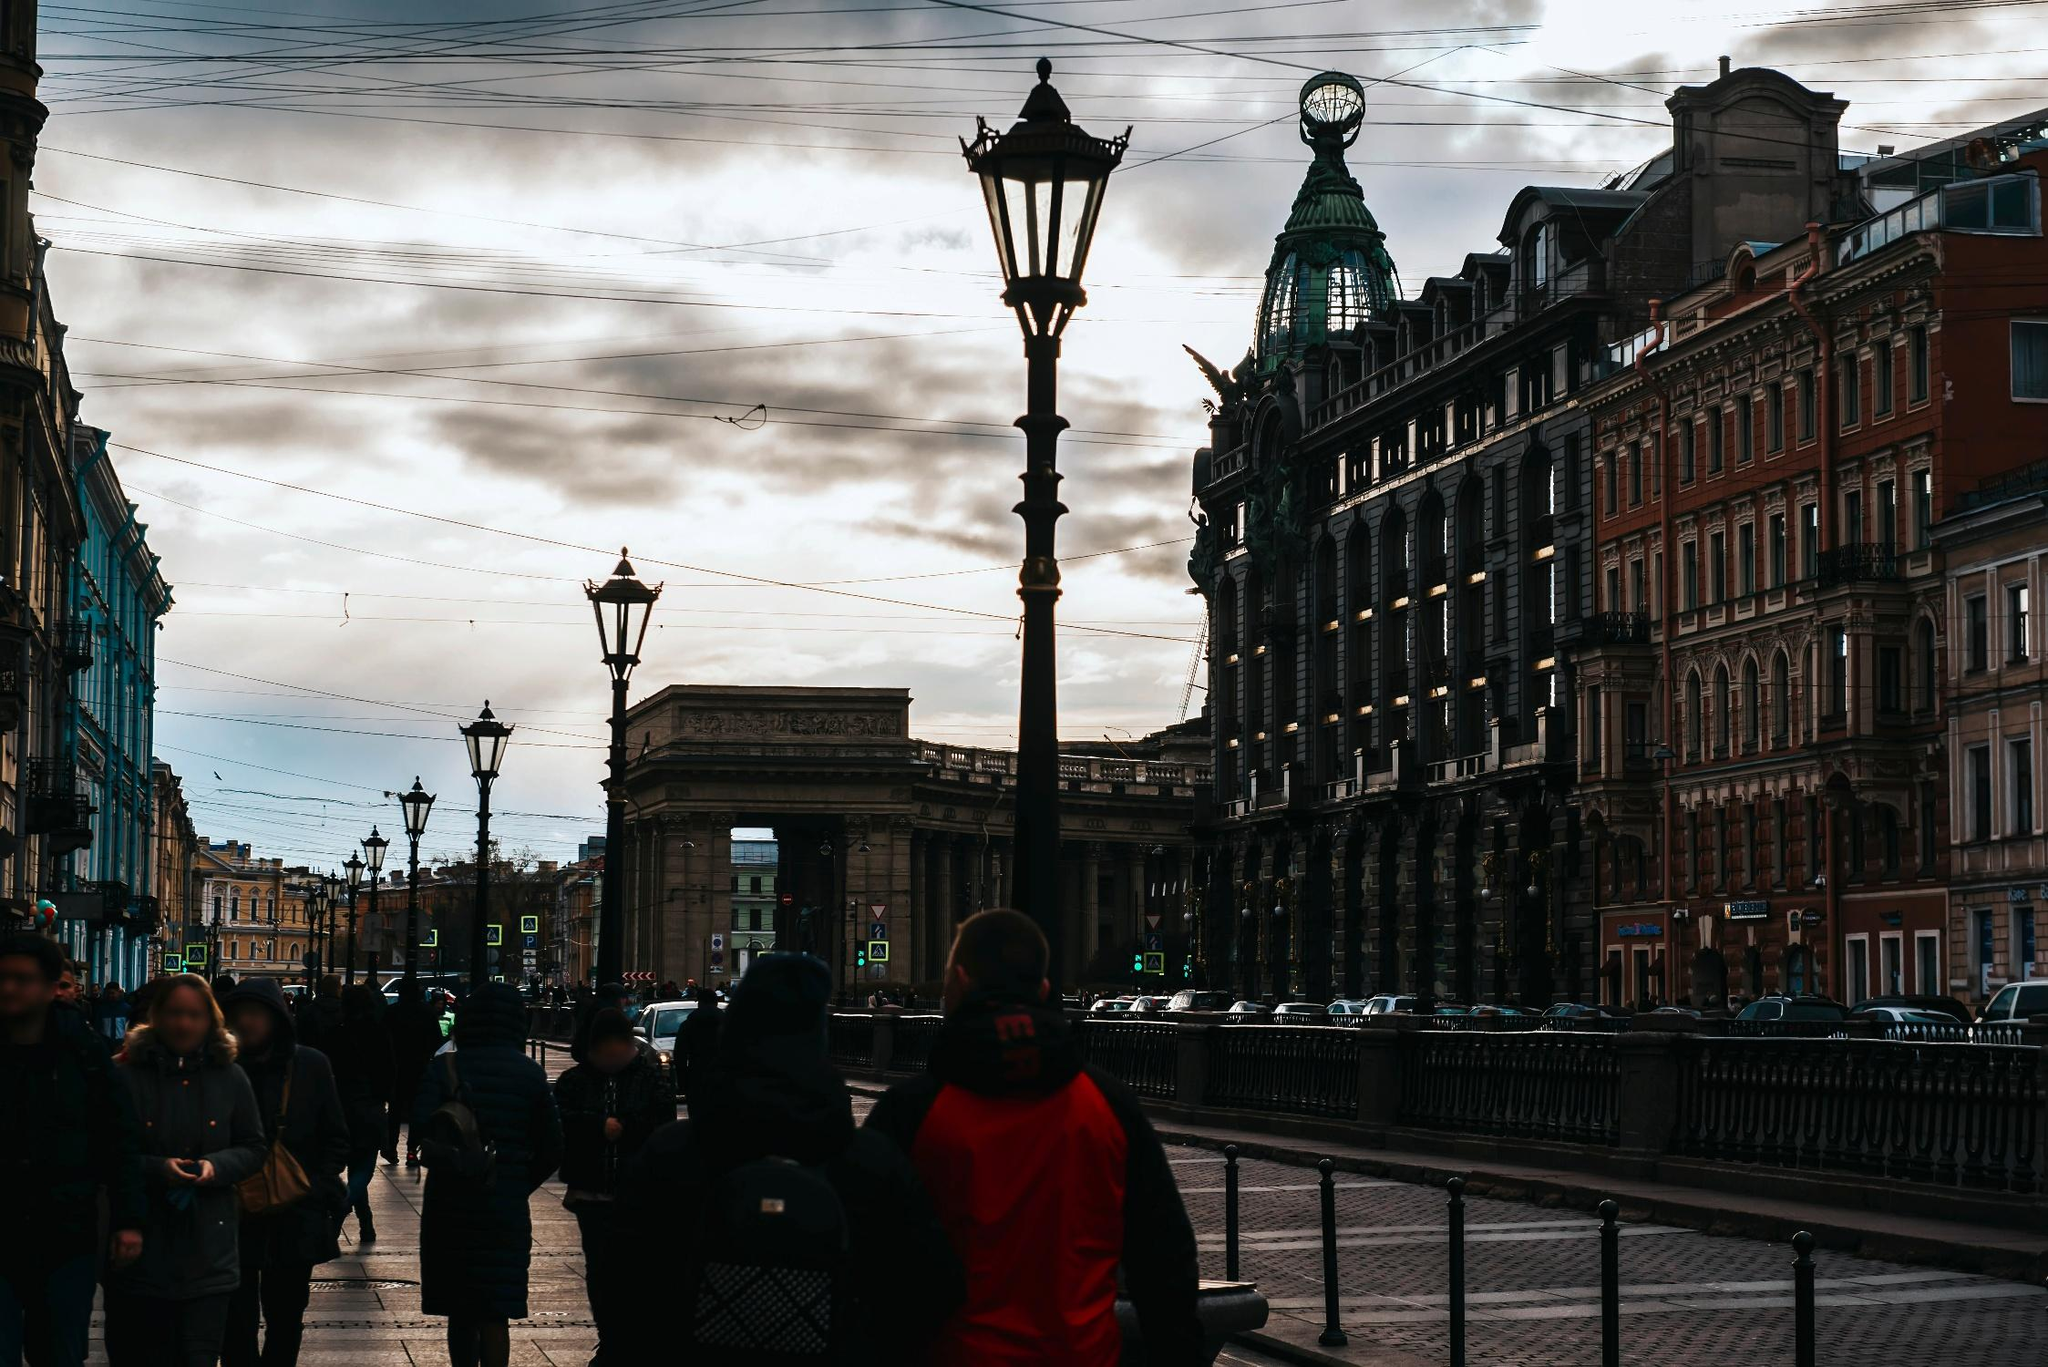Can you tell me more about the architectural style visible in the buildings? The buildings in the image are exemplary of Beaux-Arts and Neo-Baroque architectural styles, common in European cities from the late 19th to early 20th centuries. The intricate detailing, robust masonry, and grandiose scale are characteristic features. Such architecture often includes elaborate decorations, statues, and a symmetrical facade, as seen in the building with the green dome and copper-roofed turret, signifying an influence of historical opulence and grand planning. 